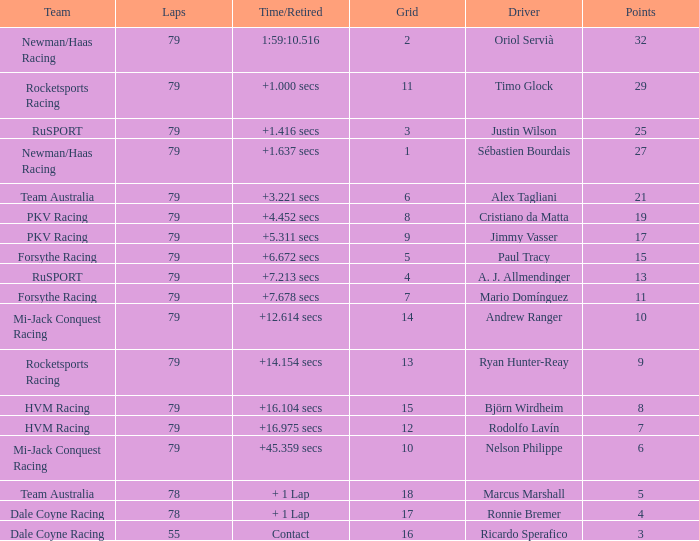Which points has the driver Paul Tracy? 15.0. 